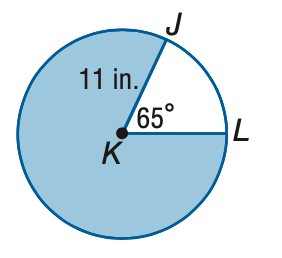Question: Find the area of the shaded sector. Round to the nearest tenth.
Choices:
A. 6.2
B. 12.5
C. 68.6
D. 311.5
Answer with the letter. Answer: D 